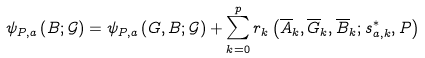Convert formula to latex. <formula><loc_0><loc_0><loc_500><loc_500>\psi _ { P , a } \left ( B ; \mathcal { G } \right ) = \psi _ { P , a } \left ( G , B ; \mathcal { G } \right ) + \sum _ { k = 0 } ^ { p } r _ { k } \left ( \overline { A } _ { k } , \overline { G } _ { k } , \overline { B } _ { k } ; s _ { a , k } ^ { \ast } , P \right )</formula> 